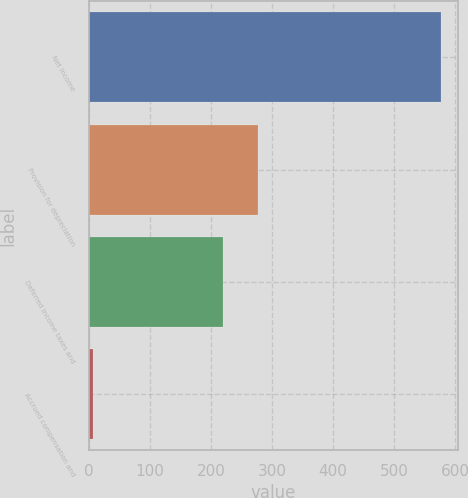<chart> <loc_0><loc_0><loc_500><loc_500><bar_chart><fcel>Net income<fcel>Provision for depreciation<fcel>Deferred income taxes and<fcel>Accrued compensation and<nl><fcel>577<fcel>277.1<fcel>220<fcel>6<nl></chart> 